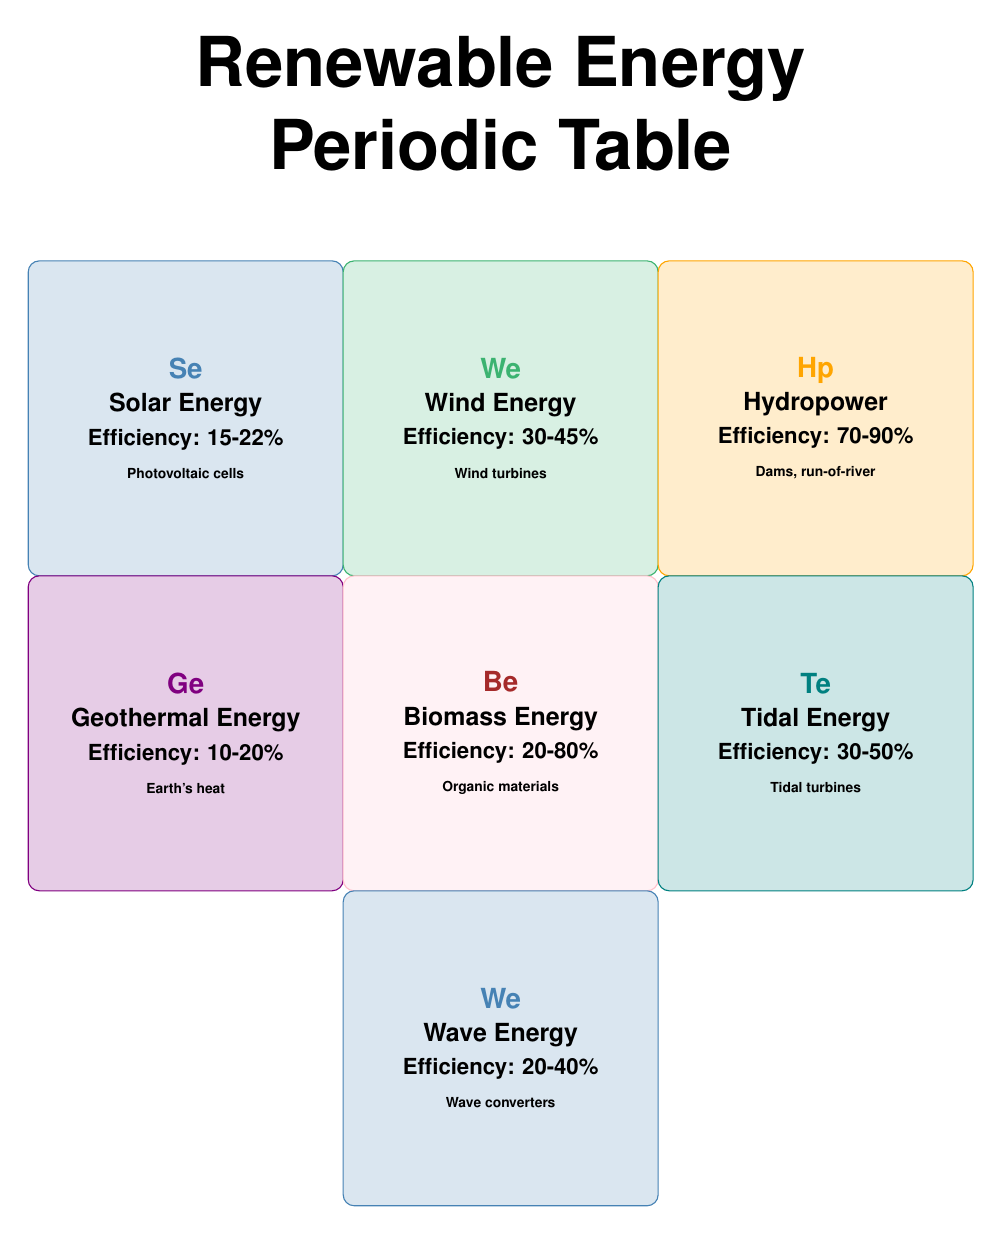What is the efficiency range of Hydropower? The table specifies that Hydropower has an efficiency of 70-90%.
Answer: 70-90% Which renewable energy source has the highest efficiency? By reviewing the efficiency values from each source, Hydropower has the highest efficiency range of 70-90%.
Answer: Hydropower What applications are associated with Wind Energy? The applications listed for Wind Energy include Electricity for Urban Areas, Rural Electrification, and Agricultural Operations.
Answer: Electricity for Urban Areas, Rural Electrification, Agricultural Operations If you combine the efficiency ranges of Solar Energy and Wave Energy, what is the total efficiency range? Solar Energy efficiency is 15-22% and Wave Energy efficiency is 20-40%. The lowest combined efficiency is 15% and the highest is 62% (22% + 40%). Hence, it can be stated as a combined range from 15% to 62%.
Answer: 15-62% Is Biomass Energy more efficient than Geothermal Energy? Comparing the efficiency ranges, Biomass Energy (20-80%) is indeed more efficient than Geothermal Energy (10-20%).
Answer: Yes Which renewable energy sources have an efficiency above 30%? From the table, the sources with efficiency above 30% include Wind Energy (30-45%), Hydropower (70-90%), Biomass Energy (20-80%), and Tidal Energy (30-50%).
Answer: Wind Energy, Hydropower, Biomass Energy, Tidal Energy What is the efficiency difference between the best and worst renewable energy sources? The best is Hydropower with 90% and the worst is Geothermal Energy with 10%, so the difference is 90% - 10% = 80%.
Answer: 80% Does Tidal Energy have an efficiency range that overlaps with either Wind Energy or Wave Energy? Tidal Energy's efficiency (30-50%) overlaps with Wind Energy (30-45%). It does not overlap with Wave Energy (20-40%).
Answer: Yes, it overlaps with Wind Energy What is the lowest efficiency among the renewable energy sources listed? The table indicates that Geothermal Energy has the lowest efficiency range of 10-20%.
Answer: 10-20% 